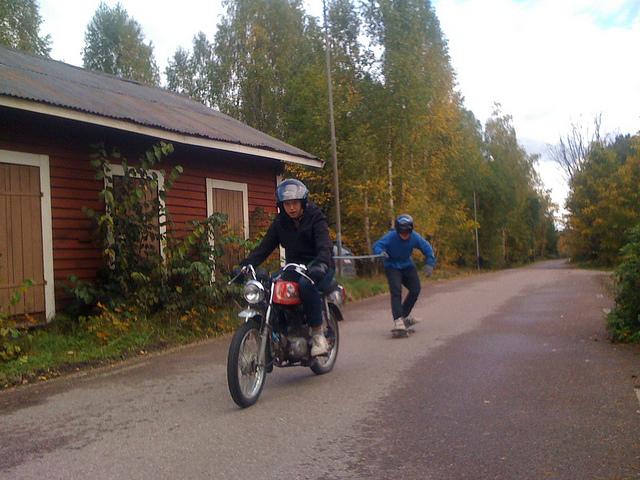Are they both riding bikes?
Short answer required. No. What is on the heads?
Give a very brief answer. Helmets. Is this safe?
Answer briefly. No. 